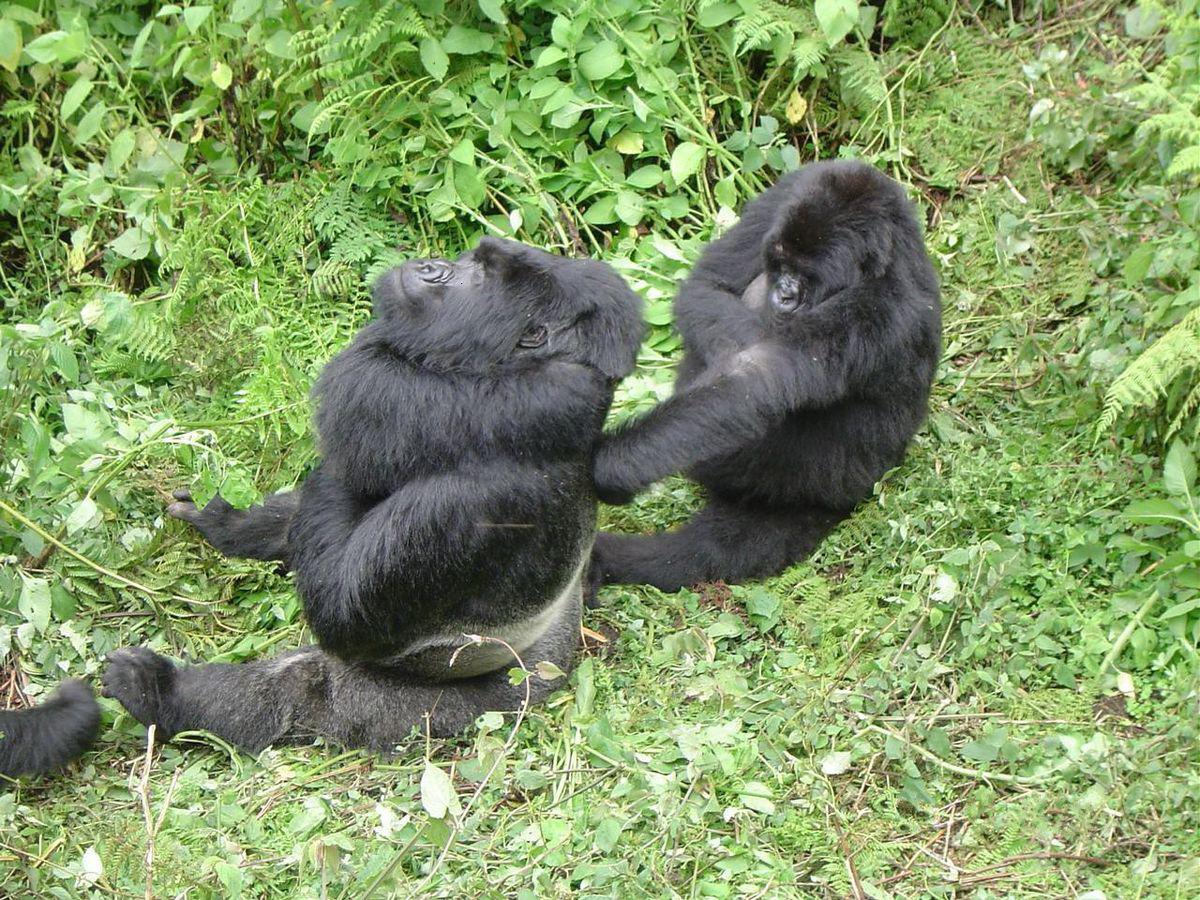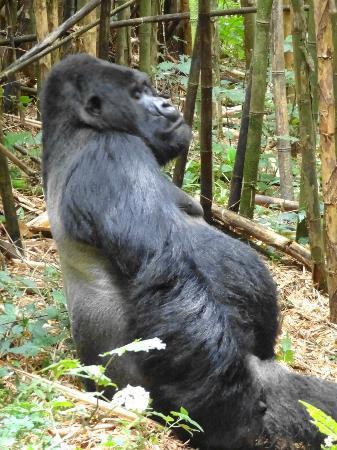The first image is the image on the left, the second image is the image on the right. Considering the images on both sides, is "The gorilla in the left image is very close to another gorilla." valid? Answer yes or no. Yes. The first image is the image on the left, the second image is the image on the right. For the images shown, is this caption "There is a single ape in the right image." true? Answer yes or no. Yes. 